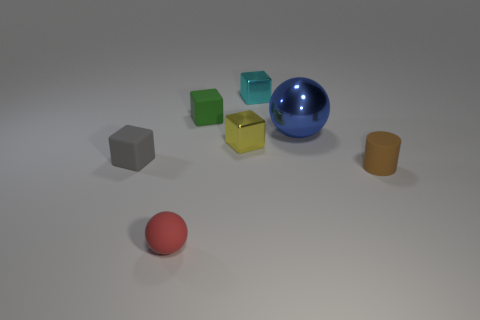Subtract all purple blocks. Subtract all green spheres. How many blocks are left? 4 Add 1 large green metallic spheres. How many objects exist? 8 Subtract all balls. How many objects are left? 5 Add 1 brown rubber cylinders. How many brown rubber cylinders exist? 2 Subtract 0 blue cubes. How many objects are left? 7 Subtract all brown metal objects. Subtract all small metallic objects. How many objects are left? 5 Add 1 tiny rubber cylinders. How many tiny rubber cylinders are left? 2 